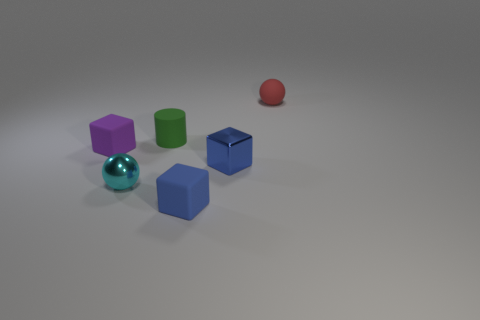Is there a small cylinder to the right of the metal object left of the tiny thing that is in front of the cyan thing?
Provide a succinct answer. Yes. There is a purple rubber thing; are there any small matte blocks on the right side of it?
Your response must be concise. Yes. What number of matte things have the same color as the shiny cube?
Your answer should be very brief. 1. What is the size of the red thing that is the same material as the green cylinder?
Offer a very short reply. Small. What size is the metallic object to the right of the sphere in front of the matte cube that is on the left side of the green cylinder?
Make the answer very short. Small. What number of cyan things are big matte cylinders or tiny shiny spheres?
Offer a very short reply. 1. Are there any purple blocks that have the same size as the red rubber sphere?
Your answer should be very brief. Yes. What is the material of the green cylinder that is the same size as the red sphere?
Offer a very short reply. Rubber. Do the ball in front of the green rubber cylinder and the ball that is behind the tiny cyan metal sphere have the same size?
Your answer should be very brief. Yes. What number of things are tiny yellow cylinders or cubes that are to the right of the small cyan metal thing?
Your response must be concise. 2. 